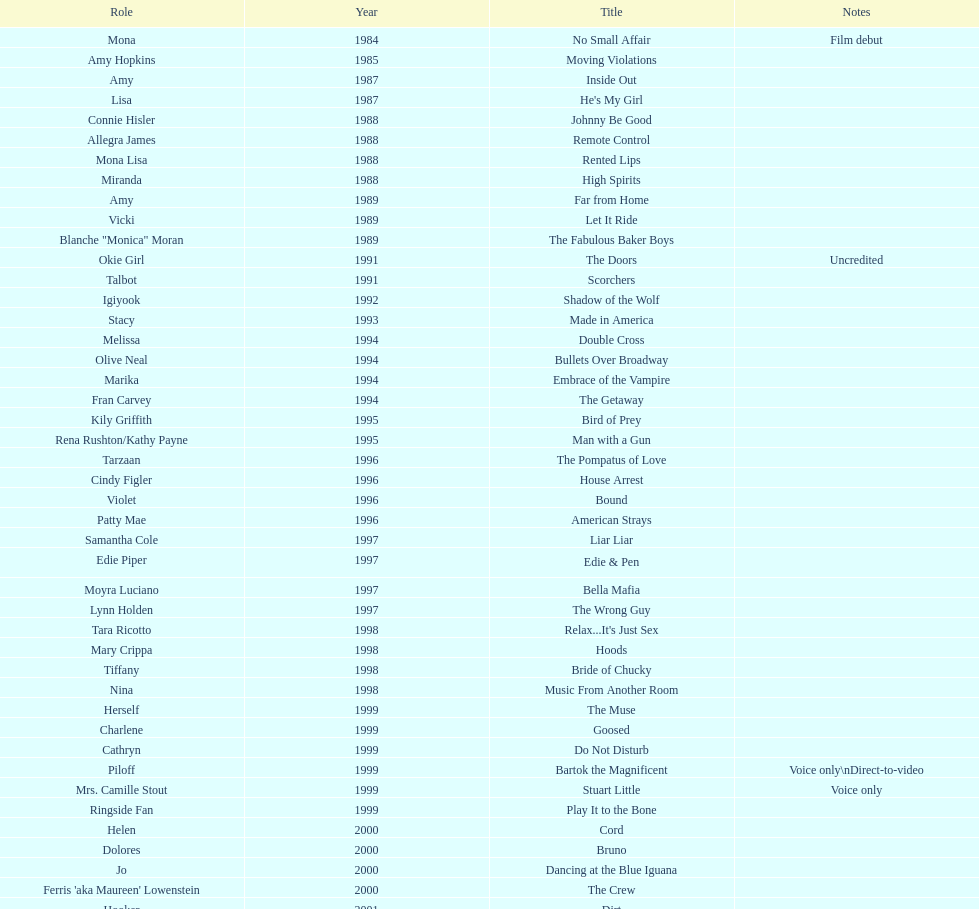How many movies does jennifer tilly play herself? 4. 